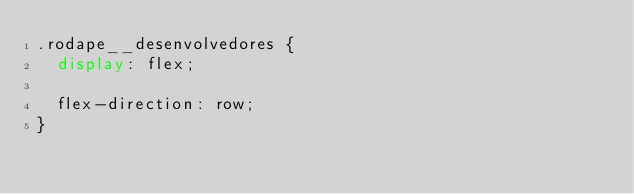<code> <loc_0><loc_0><loc_500><loc_500><_CSS_>.rodape__desenvolvedores {
  display: flex;

  flex-direction: row;
}
</code> 